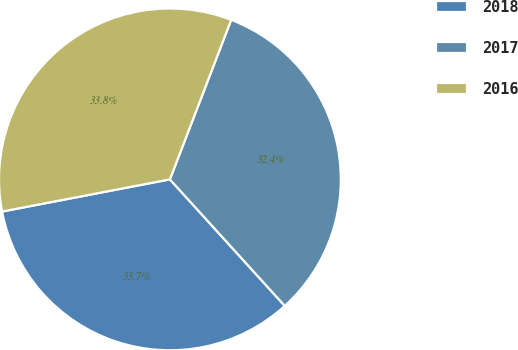Convert chart to OTSL. <chart><loc_0><loc_0><loc_500><loc_500><pie_chart><fcel>2018<fcel>2017<fcel>2016<nl><fcel>33.72%<fcel>32.43%<fcel>33.85%<nl></chart> 